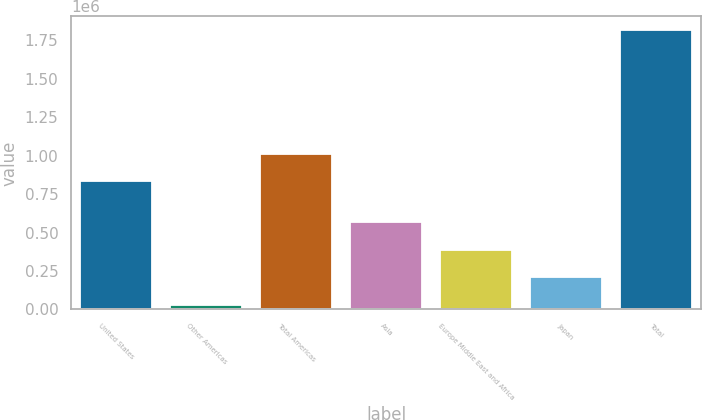Convert chart. <chart><loc_0><loc_0><loc_500><loc_500><bar_chart><fcel>United States<fcel>Other Americas<fcel>Total Americas<fcel>Asia<fcel>Europe Middle East and Africa<fcel>Japan<fcel>Total<nl><fcel>832583<fcel>31296<fcel>1.01106e+06<fcel>566732<fcel>388253<fcel>209775<fcel>1.81608e+06<nl></chart> 